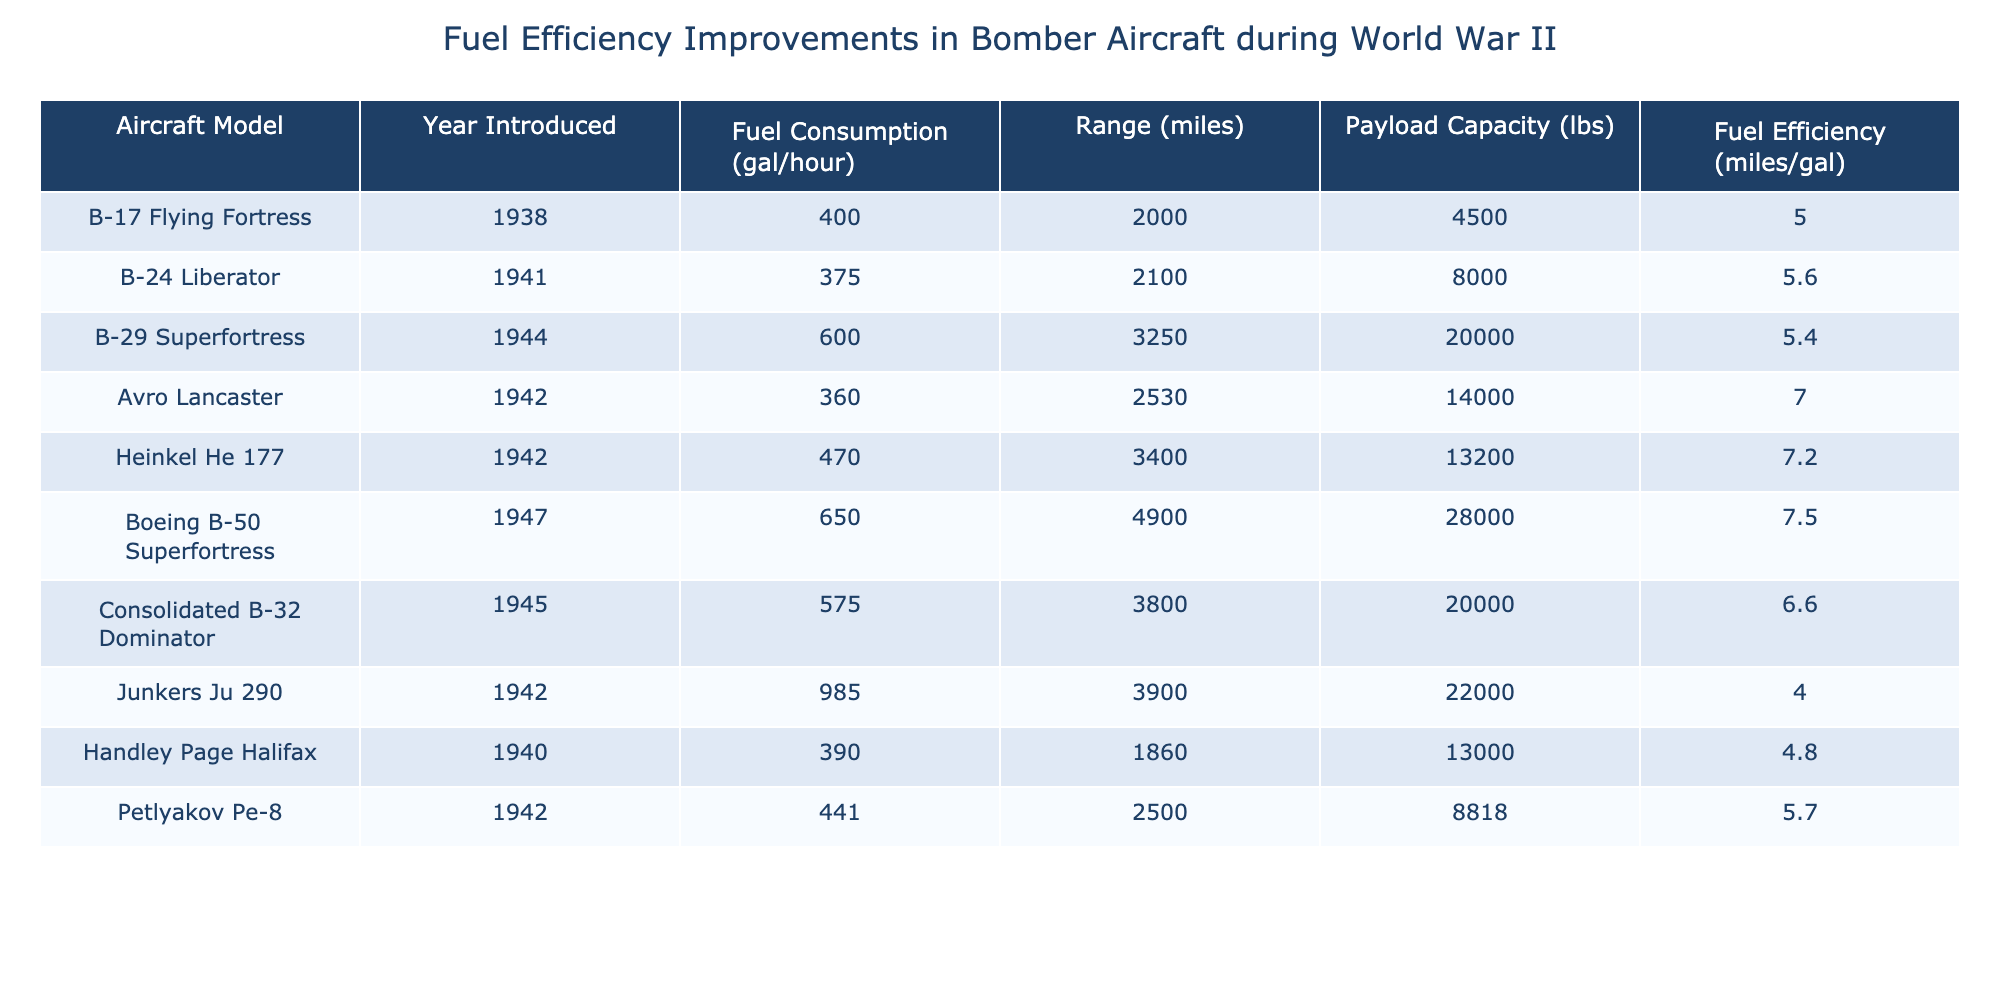What is the fuel consumption rate of the B-29 Superfortress? The table lists the fuel consumption of the B-29 Superfortress as 600 gallons per hour.
Answer: 600 gallons per hour Which aircraft has the highest fuel efficiency? The table shows that the Boeing B-50 Superfortress has the highest fuel efficiency at 7.5 miles per gallon.
Answer: Boeing B-50 Superfortress What is the range of the Avro Lancaster? According to the table, the Avro Lancaster has a range of 2,530 miles.
Answer: 2,530 miles What is the average fuel efficiency of all aircraft listed? First, sum the fuel efficiencies: 5.0 + 5.6 + 5.4 + 7.0 + 7.2 + 7.5 + 6.6 + 4.0 + 4.8 + 5.7 = 59.8. There are 10 aircraft models, so the average is 59.8 / 10 = 5.98 miles per gallon.
Answer: 5.98 miles per gallon Did the B-24 Liberator have a higher fuel efficiency than the B-17 Flying Fortress? The B-24 Liberator has a fuel efficiency of 5.6 miles per gallon, and the B-17 Flying Fortress has 5.0 miles per gallon. Since 5.6 is greater than 5.0, the statement is true.
Answer: Yes Which aircraft has a higher range, the Heinkel He 177 or the Junkers Ju 290? The range of the Heinkel He 177 is 3,400 miles, while the Junkers Ju 290 has a range of 3,900 miles. Since 3,900 is greater than 3,400, the Junkers Ju 290 has the higher range.
Answer: Junkers Ju 290 If you combine the payload capacities of the B-29 Superfortress and the Consolidated B-32 Dominator, what is the total payload? The payload of the B-29 Superfortress is 20,000 lbs and the Consolidated B-32 Dominator is also 20,000 lbs. Adding these gives a total of 20,000 + 20,000 = 40,000 lbs.
Answer: 40,000 lbs Which aircraft entered service first, the Handley Page Halifax or the B-24 Liberator? The Handley Page Halifax was introduced in 1940, while the B-24 Liberator was introduced in 1941. Since 1940 is earlier than 1941, the Handley Page Halifax entered service first.
Answer: Handley Page Halifax What is the difference in fuel consumption between the Junkers Ju 290 and the Avro Lancaster? The fuel consumption of the Junkers Ju 290 is 985 gallons per hour, and the Avro Lancaster is 360 gallons per hour. The difference is 985 - 360 = 625 gallons per hour.
Answer: 625 gallons per hour Is the fuel efficiency of the Heinkel He 177 greater than 7 miles per gallon? The fuel efficiency of the Heinkel He 177 is 7.2 miles per gallon. Since 7.2 is greater than 7, the statement is true.
Answer: Yes 